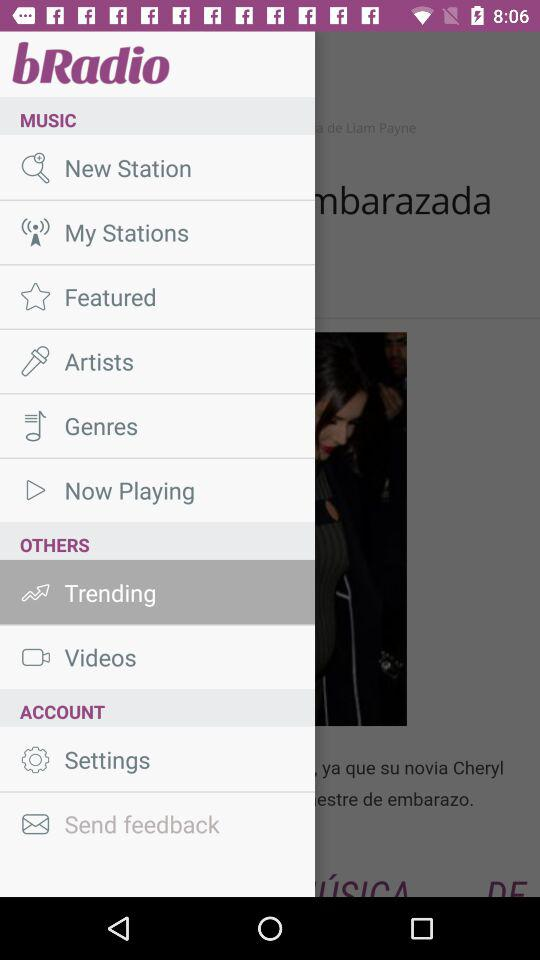Who are the singers listed in "Artists"?
When the provided information is insufficient, respond with <no answer>. <no answer> 